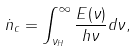Convert formula to latex. <formula><loc_0><loc_0><loc_500><loc_500>\dot { n } _ { c } = \int _ { \nu _ { H } } ^ { \infty } \frac { E ( \nu ) } { h \nu } d \nu ,</formula> 